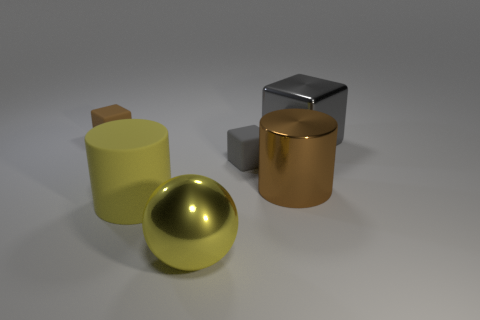Can you tell me something about the lighting in this scene? The lighting in the scene is soft and diffuse, casting gentle shadows beneath the objects. The light source seems to be coming from above, as indicated by the positioning of the shadows, creating a calm and balanced atmosphere. 